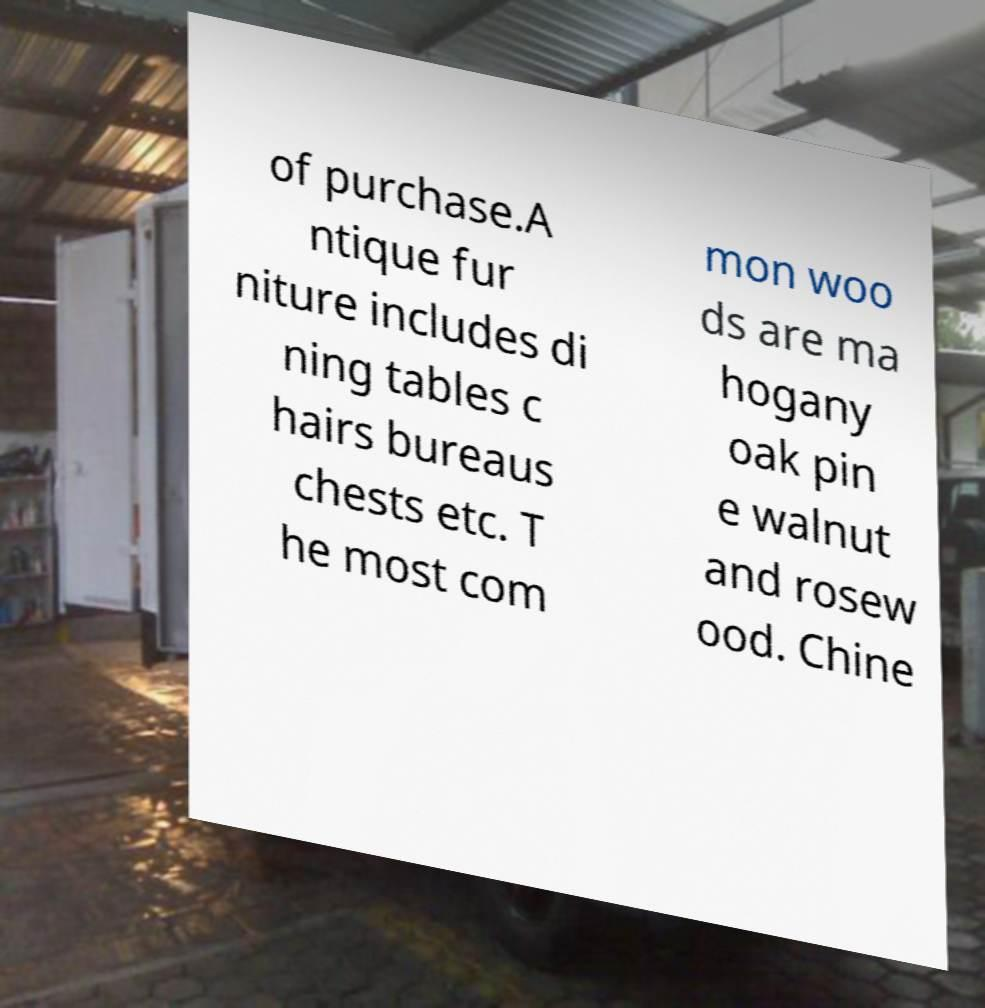Can you read and provide the text displayed in the image?This photo seems to have some interesting text. Can you extract and type it out for me? of purchase.A ntique fur niture includes di ning tables c hairs bureaus chests etc. T he most com mon woo ds are ma hogany oak pin e walnut and rosew ood. Chine 